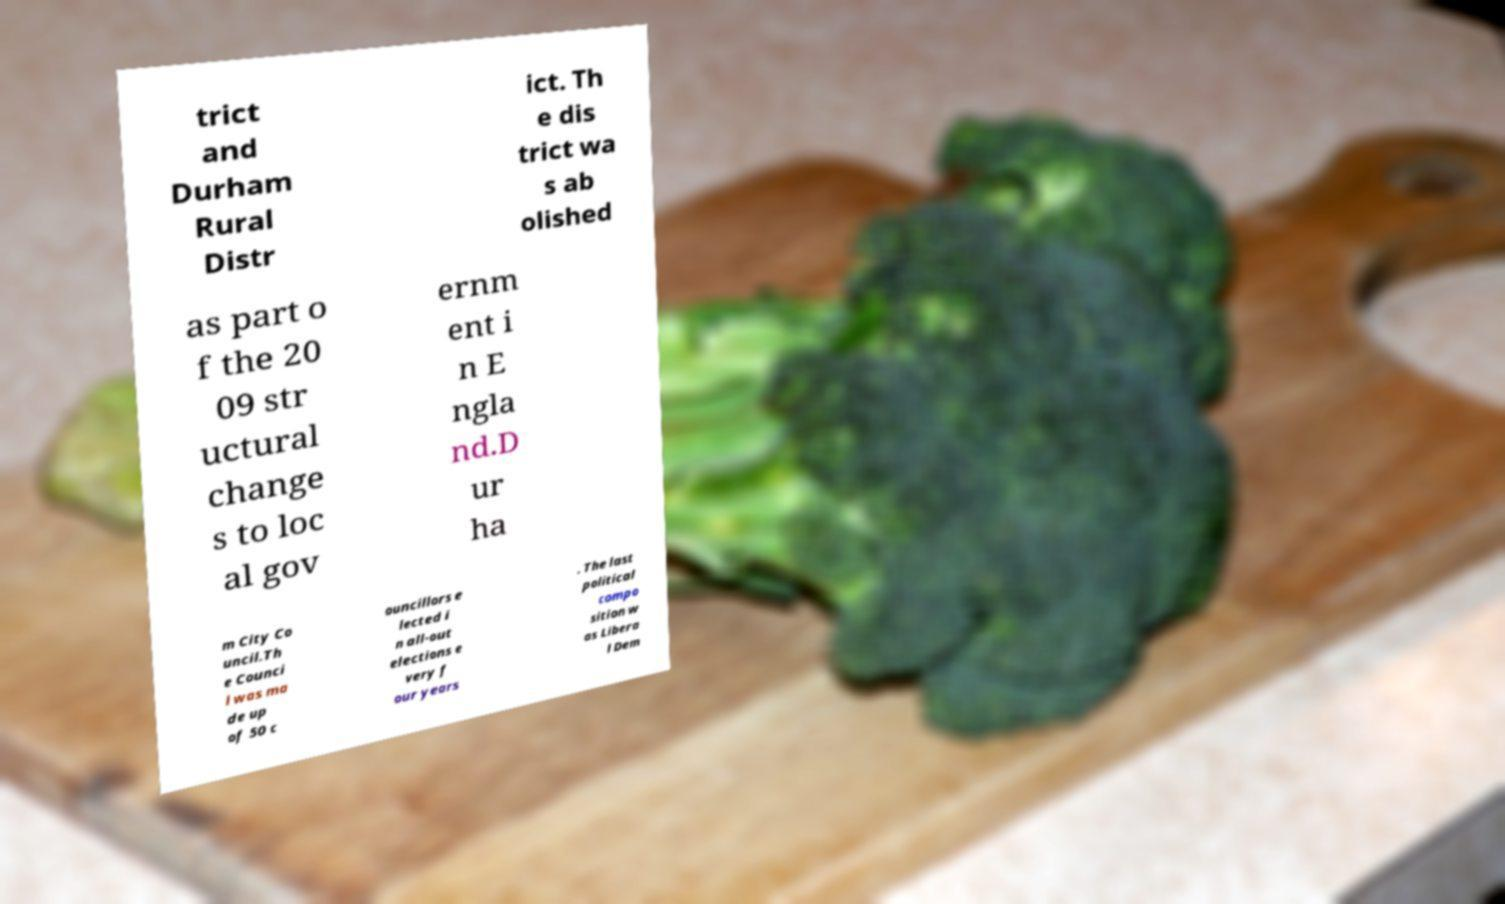Can you read and provide the text displayed in the image?This photo seems to have some interesting text. Can you extract and type it out for me? trict and Durham Rural Distr ict. Th e dis trict wa s ab olished as part o f the 20 09 str uctural change s to loc al gov ernm ent i n E ngla nd.D ur ha m City Co uncil.Th e Counci l was ma de up of 50 c ouncillors e lected i n all-out elections e very f our years . The last political compo sition w as Libera l Dem 